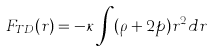Convert formula to latex. <formula><loc_0><loc_0><loc_500><loc_500>F _ { T D } ( r ) = - \kappa \int ( \rho + 2 p ) r ^ { 2 } d r</formula> 